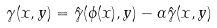Convert formula to latex. <formula><loc_0><loc_0><loc_500><loc_500>\gamma ( x , y ) = \hat { \gamma } ( \phi ( x ) , y ) - \alpha \hat { \gamma } ( x , y )</formula> 